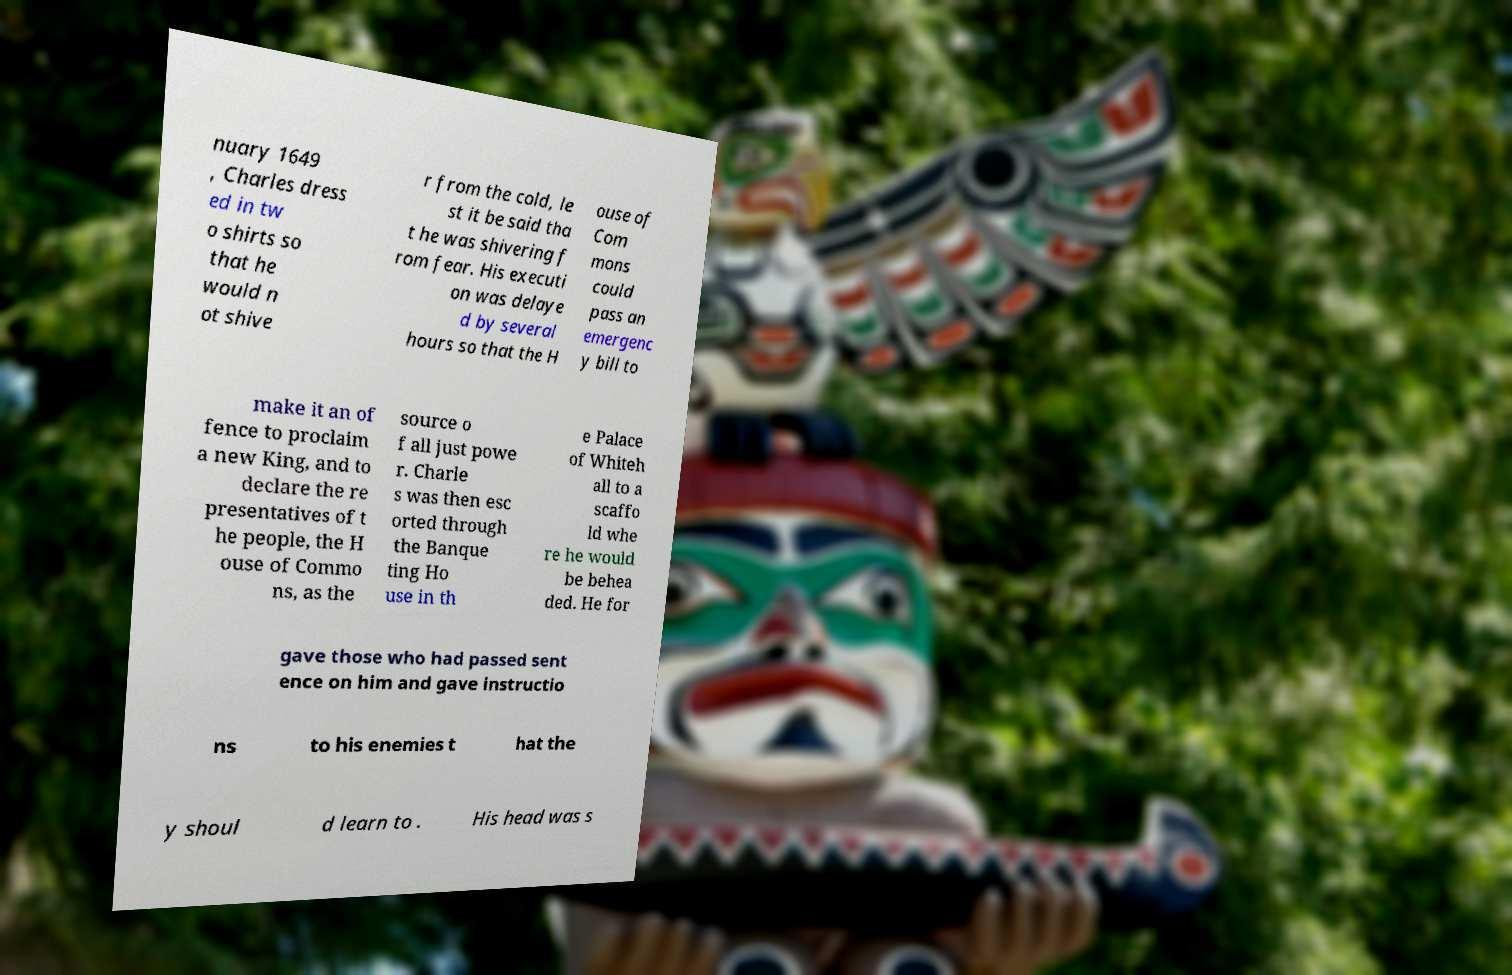I need the written content from this picture converted into text. Can you do that? nuary 1649 , Charles dress ed in tw o shirts so that he would n ot shive r from the cold, le st it be said tha t he was shivering f rom fear. His executi on was delaye d by several hours so that the H ouse of Com mons could pass an emergenc y bill to make it an of fence to proclaim a new King, and to declare the re presentatives of t he people, the H ouse of Commo ns, as the source o f all just powe r. Charle s was then esc orted through the Banque ting Ho use in th e Palace of Whiteh all to a scaffo ld whe re he would be behea ded. He for gave those who had passed sent ence on him and gave instructio ns to his enemies t hat the y shoul d learn to . His head was s 